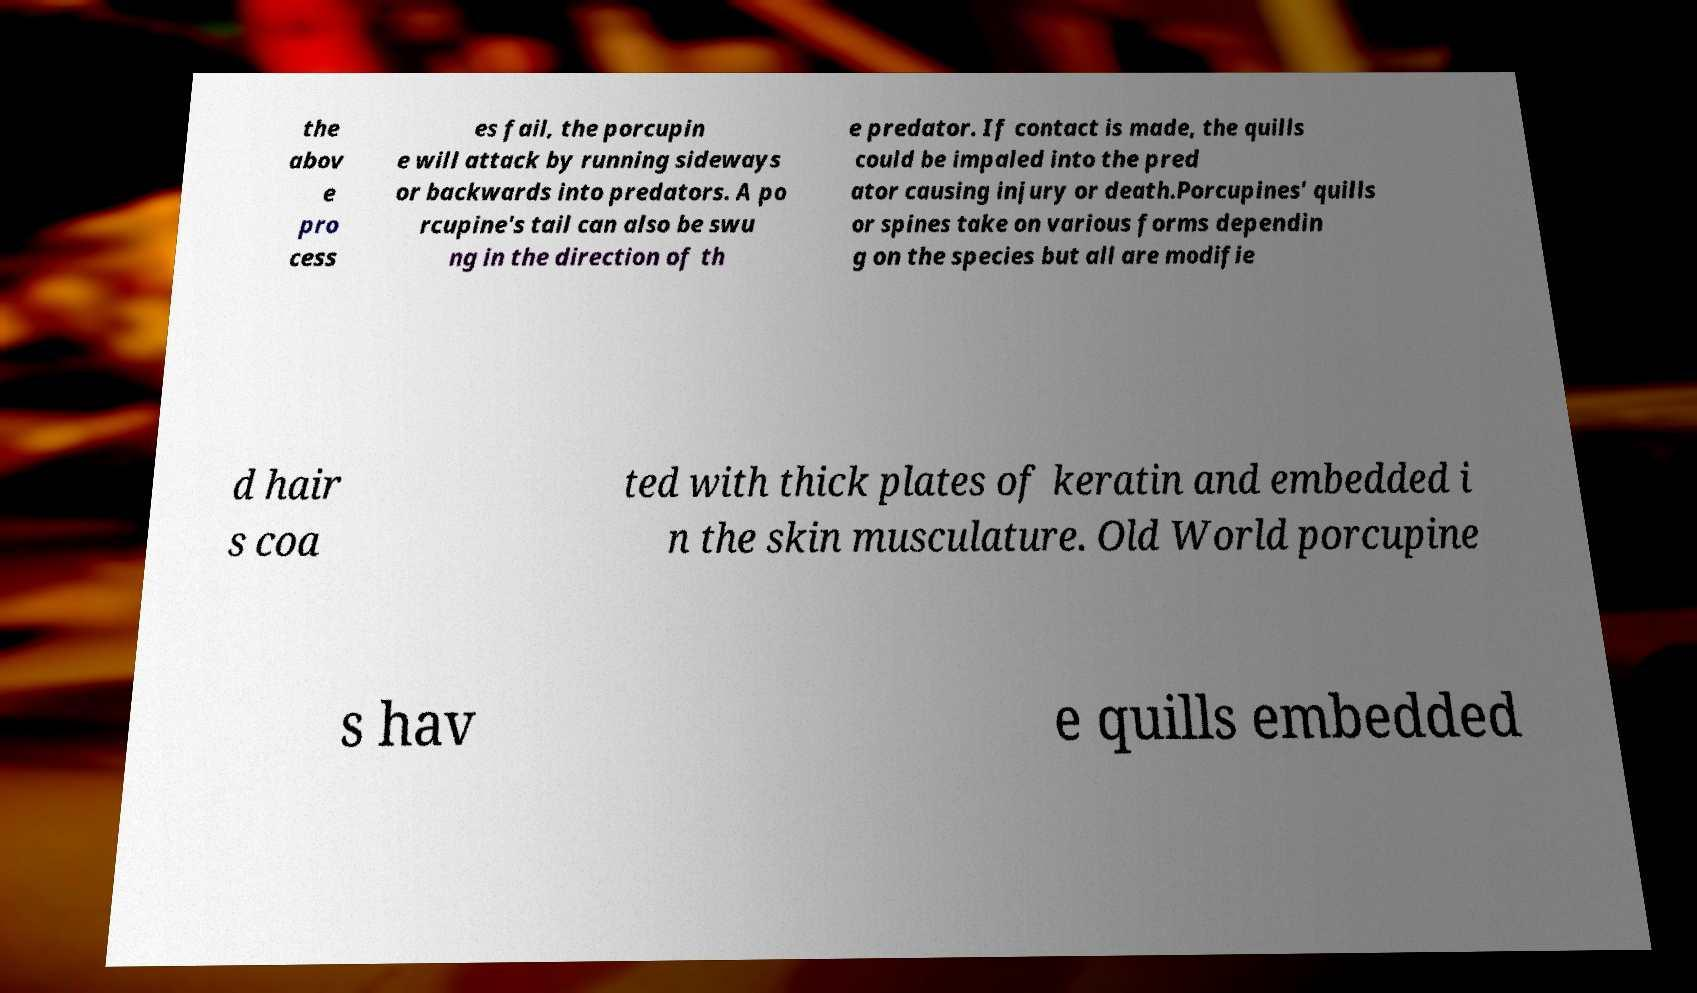There's text embedded in this image that I need extracted. Can you transcribe it verbatim? the abov e pro cess es fail, the porcupin e will attack by running sideways or backwards into predators. A po rcupine's tail can also be swu ng in the direction of th e predator. If contact is made, the quills could be impaled into the pred ator causing injury or death.Porcupines' quills or spines take on various forms dependin g on the species but all are modifie d hair s coa ted with thick plates of keratin and embedded i n the skin musculature. Old World porcupine s hav e quills embedded 